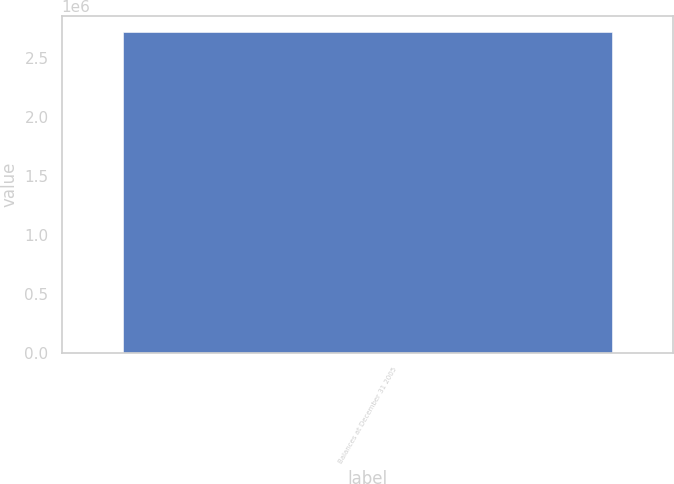<chart> <loc_0><loc_0><loc_500><loc_500><bar_chart><fcel>Balances at December 31 2005<nl><fcel>2.7161e+06<nl></chart> 